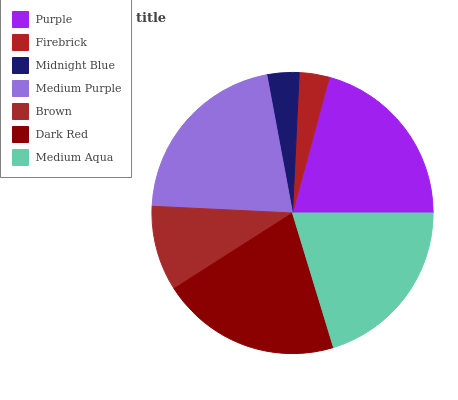Is Firebrick the minimum?
Answer yes or no. Yes. Is Medium Purple the maximum?
Answer yes or no. Yes. Is Midnight Blue the minimum?
Answer yes or no. No. Is Midnight Blue the maximum?
Answer yes or no. No. Is Midnight Blue greater than Firebrick?
Answer yes or no. Yes. Is Firebrick less than Midnight Blue?
Answer yes or no. Yes. Is Firebrick greater than Midnight Blue?
Answer yes or no. No. Is Midnight Blue less than Firebrick?
Answer yes or no. No. Is Medium Aqua the high median?
Answer yes or no. Yes. Is Medium Aqua the low median?
Answer yes or no. Yes. Is Firebrick the high median?
Answer yes or no. No. Is Midnight Blue the low median?
Answer yes or no. No. 